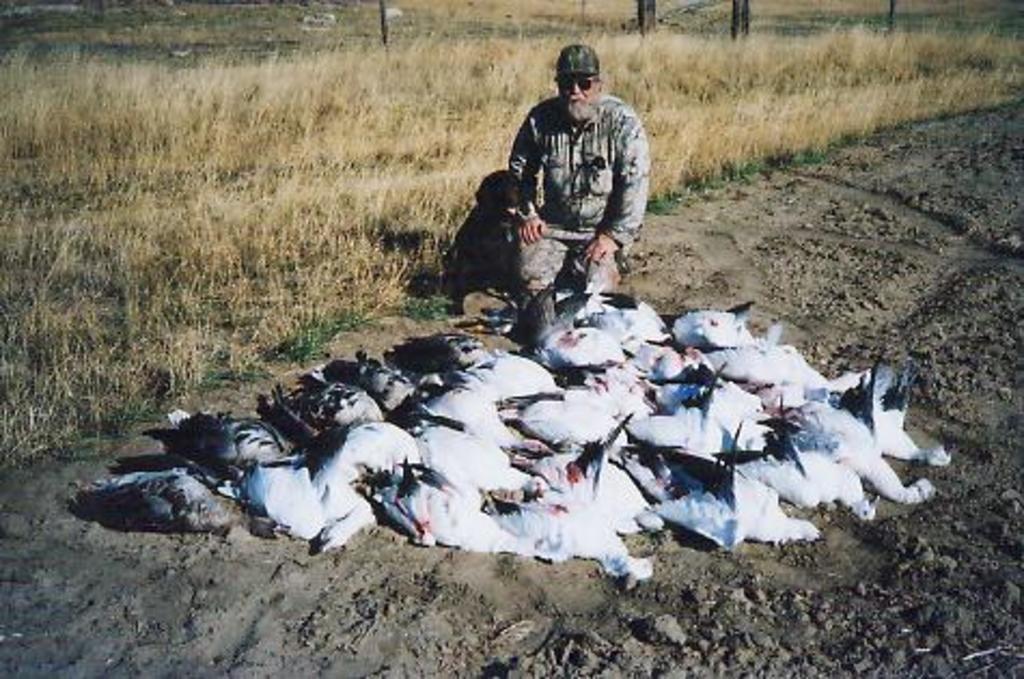How would you summarize this image in a sentence or two? In this image there are so many birds laying on the path, and at the background there is a person in a squat position, grass. 